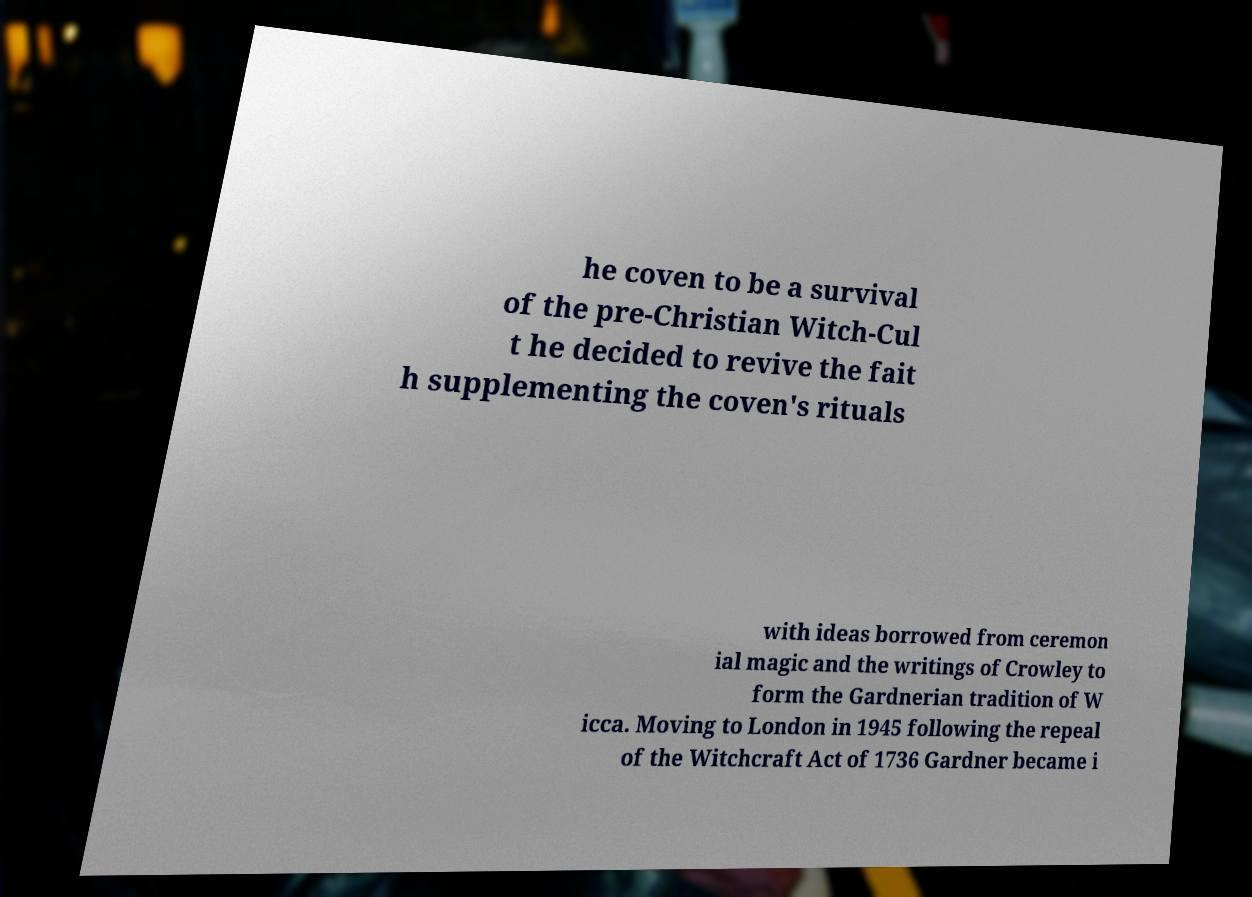I need the written content from this picture converted into text. Can you do that? he coven to be a survival of the pre-Christian Witch-Cul t he decided to revive the fait h supplementing the coven's rituals with ideas borrowed from ceremon ial magic and the writings of Crowley to form the Gardnerian tradition of W icca. Moving to London in 1945 following the repeal of the Witchcraft Act of 1736 Gardner became i 